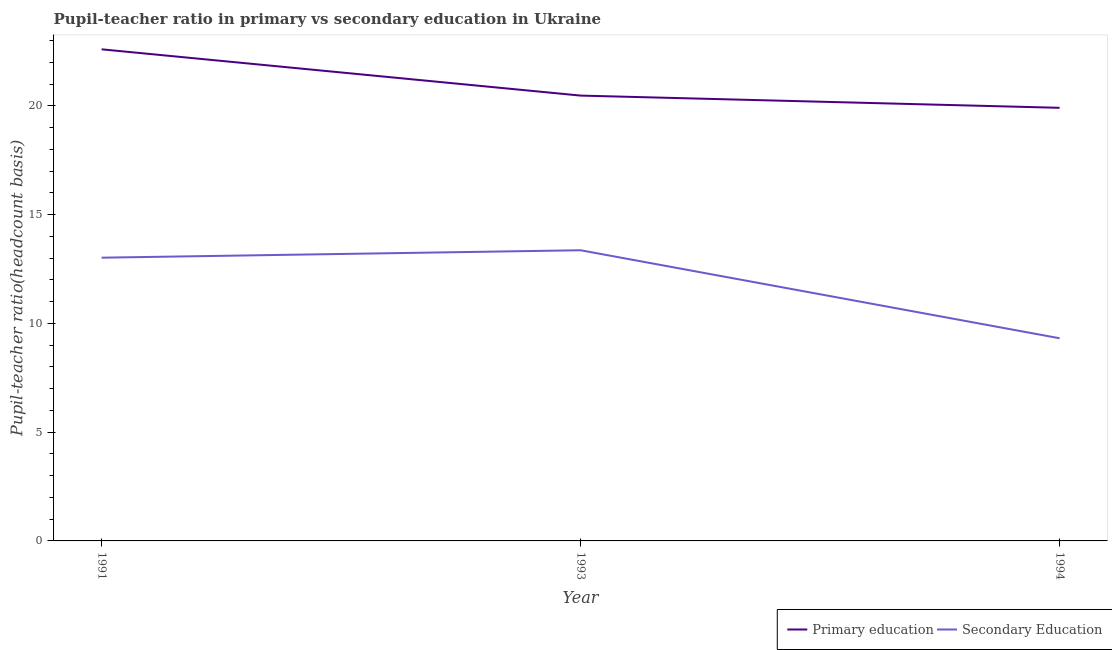Does the line corresponding to pupil teacher ratio on secondary education intersect with the line corresponding to pupil-teacher ratio in primary education?
Give a very brief answer. No. Is the number of lines equal to the number of legend labels?
Give a very brief answer. Yes. What is the pupil teacher ratio on secondary education in 1991?
Provide a succinct answer. 13.02. Across all years, what is the maximum pupil teacher ratio on secondary education?
Keep it short and to the point. 13.37. Across all years, what is the minimum pupil teacher ratio on secondary education?
Keep it short and to the point. 9.32. In which year was the pupil-teacher ratio in primary education minimum?
Offer a terse response. 1994. What is the total pupil-teacher ratio in primary education in the graph?
Offer a very short reply. 63. What is the difference between the pupil-teacher ratio in primary education in 1991 and that in 1993?
Your answer should be compact. 2.13. What is the difference between the pupil-teacher ratio in primary education in 1991 and the pupil teacher ratio on secondary education in 1993?
Give a very brief answer. 9.24. What is the average pupil-teacher ratio in primary education per year?
Give a very brief answer. 21. In the year 1994, what is the difference between the pupil teacher ratio on secondary education and pupil-teacher ratio in primary education?
Give a very brief answer. -10.6. In how many years, is the pupil teacher ratio on secondary education greater than 13?
Keep it short and to the point. 2. What is the ratio of the pupil teacher ratio on secondary education in 1991 to that in 1993?
Ensure brevity in your answer.  0.97. Is the pupil-teacher ratio in primary education in 1991 less than that in 1994?
Keep it short and to the point. No. Is the difference between the pupil-teacher ratio in primary education in 1991 and 1994 greater than the difference between the pupil teacher ratio on secondary education in 1991 and 1994?
Keep it short and to the point. No. What is the difference between the highest and the second highest pupil teacher ratio on secondary education?
Offer a terse response. 0.34. What is the difference between the highest and the lowest pupil-teacher ratio in primary education?
Make the answer very short. 2.69. In how many years, is the pupil-teacher ratio in primary education greater than the average pupil-teacher ratio in primary education taken over all years?
Provide a short and direct response. 1. Does the pupil-teacher ratio in primary education monotonically increase over the years?
Give a very brief answer. No. Is the pupil teacher ratio on secondary education strictly greater than the pupil-teacher ratio in primary education over the years?
Make the answer very short. No. How many lines are there?
Offer a terse response. 2. What is the difference between two consecutive major ticks on the Y-axis?
Give a very brief answer. 5. Does the graph contain any zero values?
Provide a succinct answer. No. How many legend labels are there?
Offer a terse response. 2. How are the legend labels stacked?
Your response must be concise. Horizontal. What is the title of the graph?
Your answer should be very brief. Pupil-teacher ratio in primary vs secondary education in Ukraine. What is the label or title of the X-axis?
Give a very brief answer. Year. What is the label or title of the Y-axis?
Offer a terse response. Pupil-teacher ratio(headcount basis). What is the Pupil-teacher ratio(headcount basis) in Primary education in 1991?
Give a very brief answer. 22.6. What is the Pupil-teacher ratio(headcount basis) of Secondary Education in 1991?
Your response must be concise. 13.02. What is the Pupil-teacher ratio(headcount basis) of Primary education in 1993?
Make the answer very short. 20.48. What is the Pupil-teacher ratio(headcount basis) of Secondary Education in 1993?
Make the answer very short. 13.37. What is the Pupil-teacher ratio(headcount basis) of Primary education in 1994?
Your answer should be very brief. 19.92. What is the Pupil-teacher ratio(headcount basis) in Secondary Education in 1994?
Keep it short and to the point. 9.32. Across all years, what is the maximum Pupil-teacher ratio(headcount basis) of Primary education?
Offer a terse response. 22.6. Across all years, what is the maximum Pupil-teacher ratio(headcount basis) in Secondary Education?
Your answer should be very brief. 13.37. Across all years, what is the minimum Pupil-teacher ratio(headcount basis) in Primary education?
Make the answer very short. 19.92. Across all years, what is the minimum Pupil-teacher ratio(headcount basis) in Secondary Education?
Your response must be concise. 9.32. What is the total Pupil-teacher ratio(headcount basis) in Primary education in the graph?
Offer a terse response. 63. What is the total Pupil-teacher ratio(headcount basis) in Secondary Education in the graph?
Your answer should be very brief. 35.71. What is the difference between the Pupil-teacher ratio(headcount basis) of Primary education in 1991 and that in 1993?
Your response must be concise. 2.13. What is the difference between the Pupil-teacher ratio(headcount basis) in Secondary Education in 1991 and that in 1993?
Your answer should be very brief. -0.34. What is the difference between the Pupil-teacher ratio(headcount basis) of Primary education in 1991 and that in 1994?
Your answer should be compact. 2.69. What is the difference between the Pupil-teacher ratio(headcount basis) of Secondary Education in 1991 and that in 1994?
Provide a short and direct response. 3.71. What is the difference between the Pupil-teacher ratio(headcount basis) of Primary education in 1993 and that in 1994?
Keep it short and to the point. 0.56. What is the difference between the Pupil-teacher ratio(headcount basis) in Secondary Education in 1993 and that in 1994?
Provide a succinct answer. 4.05. What is the difference between the Pupil-teacher ratio(headcount basis) in Primary education in 1991 and the Pupil-teacher ratio(headcount basis) in Secondary Education in 1993?
Give a very brief answer. 9.24. What is the difference between the Pupil-teacher ratio(headcount basis) in Primary education in 1991 and the Pupil-teacher ratio(headcount basis) in Secondary Education in 1994?
Provide a succinct answer. 13.29. What is the difference between the Pupil-teacher ratio(headcount basis) in Primary education in 1993 and the Pupil-teacher ratio(headcount basis) in Secondary Education in 1994?
Provide a short and direct response. 11.16. What is the average Pupil-teacher ratio(headcount basis) in Primary education per year?
Your response must be concise. 21. What is the average Pupil-teacher ratio(headcount basis) of Secondary Education per year?
Your response must be concise. 11.9. In the year 1991, what is the difference between the Pupil-teacher ratio(headcount basis) of Primary education and Pupil-teacher ratio(headcount basis) of Secondary Education?
Offer a terse response. 9.58. In the year 1993, what is the difference between the Pupil-teacher ratio(headcount basis) in Primary education and Pupil-teacher ratio(headcount basis) in Secondary Education?
Offer a terse response. 7.11. In the year 1994, what is the difference between the Pupil-teacher ratio(headcount basis) of Primary education and Pupil-teacher ratio(headcount basis) of Secondary Education?
Your answer should be compact. 10.6. What is the ratio of the Pupil-teacher ratio(headcount basis) in Primary education in 1991 to that in 1993?
Give a very brief answer. 1.1. What is the ratio of the Pupil-teacher ratio(headcount basis) in Secondary Education in 1991 to that in 1993?
Provide a succinct answer. 0.97. What is the ratio of the Pupil-teacher ratio(headcount basis) in Primary education in 1991 to that in 1994?
Your response must be concise. 1.14. What is the ratio of the Pupil-teacher ratio(headcount basis) of Secondary Education in 1991 to that in 1994?
Keep it short and to the point. 1.4. What is the ratio of the Pupil-teacher ratio(headcount basis) in Primary education in 1993 to that in 1994?
Your answer should be very brief. 1.03. What is the ratio of the Pupil-teacher ratio(headcount basis) of Secondary Education in 1993 to that in 1994?
Provide a short and direct response. 1.43. What is the difference between the highest and the second highest Pupil-teacher ratio(headcount basis) in Primary education?
Provide a short and direct response. 2.13. What is the difference between the highest and the second highest Pupil-teacher ratio(headcount basis) of Secondary Education?
Make the answer very short. 0.34. What is the difference between the highest and the lowest Pupil-teacher ratio(headcount basis) in Primary education?
Your answer should be compact. 2.69. What is the difference between the highest and the lowest Pupil-teacher ratio(headcount basis) in Secondary Education?
Offer a very short reply. 4.05. 